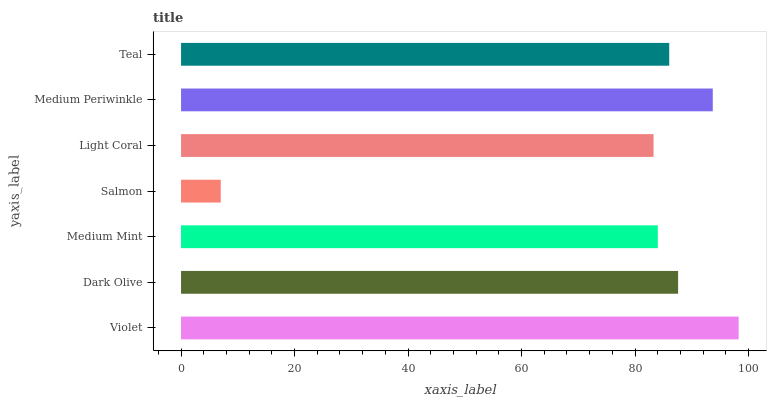Is Salmon the minimum?
Answer yes or no. Yes. Is Violet the maximum?
Answer yes or no. Yes. Is Dark Olive the minimum?
Answer yes or no. No. Is Dark Olive the maximum?
Answer yes or no. No. Is Violet greater than Dark Olive?
Answer yes or no. Yes. Is Dark Olive less than Violet?
Answer yes or no. Yes. Is Dark Olive greater than Violet?
Answer yes or no. No. Is Violet less than Dark Olive?
Answer yes or no. No. Is Teal the high median?
Answer yes or no. Yes. Is Teal the low median?
Answer yes or no. Yes. Is Medium Mint the high median?
Answer yes or no. No. Is Dark Olive the low median?
Answer yes or no. No. 